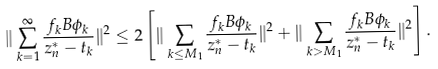<formula> <loc_0><loc_0><loc_500><loc_500>\| \sum _ { k = 1 } ^ { \infty } \frac { f _ { k } B \phi _ { k } } { z ^ { * } _ { n } - t _ { k } } \| ^ { 2 } \leq 2 \left [ \| \sum _ { k \leq M _ { 1 } } \frac { f _ { k } B \phi _ { k } } { z ^ { * } _ { n } - t _ { k } } \| ^ { 2 } + \| \sum _ { k > M _ { 1 } } \frac { f _ { k } B \phi _ { k } } { z ^ { * } _ { n } - t _ { k } } \| ^ { 2 } \right ] .</formula> 